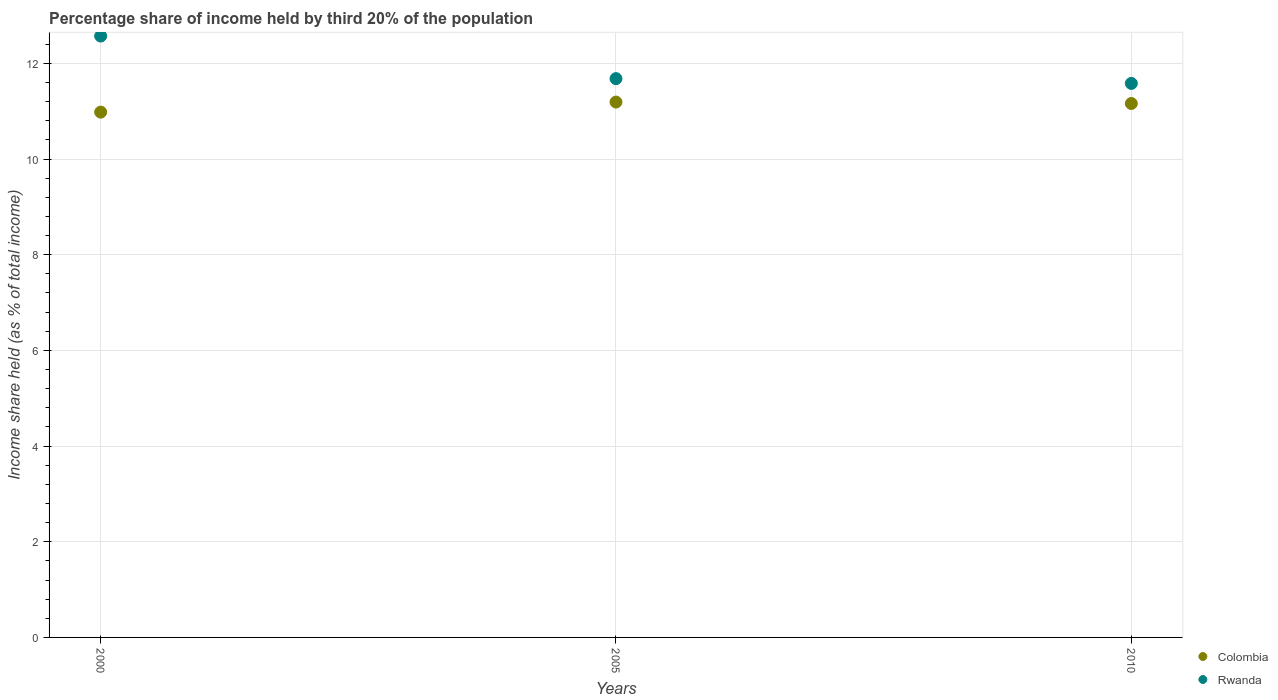How many different coloured dotlines are there?
Your answer should be compact. 2. What is the share of income held by third 20% of the population in Colombia in 2000?
Make the answer very short. 10.98. Across all years, what is the maximum share of income held by third 20% of the population in Colombia?
Offer a very short reply. 11.19. Across all years, what is the minimum share of income held by third 20% of the population in Colombia?
Keep it short and to the point. 10.98. In which year was the share of income held by third 20% of the population in Colombia minimum?
Your response must be concise. 2000. What is the total share of income held by third 20% of the population in Rwanda in the graph?
Ensure brevity in your answer.  35.83. What is the difference between the share of income held by third 20% of the population in Rwanda in 2000 and that in 2010?
Offer a terse response. 0.99. What is the difference between the share of income held by third 20% of the population in Colombia in 2005 and the share of income held by third 20% of the population in Rwanda in 2000?
Your answer should be compact. -1.38. What is the average share of income held by third 20% of the population in Colombia per year?
Your answer should be compact. 11.11. In the year 2000, what is the difference between the share of income held by third 20% of the population in Rwanda and share of income held by third 20% of the population in Colombia?
Provide a short and direct response. 1.59. What is the ratio of the share of income held by third 20% of the population in Rwanda in 2000 to that in 2005?
Provide a short and direct response. 1.08. What is the difference between the highest and the second highest share of income held by third 20% of the population in Colombia?
Keep it short and to the point. 0.03. What is the difference between the highest and the lowest share of income held by third 20% of the population in Rwanda?
Give a very brief answer. 0.99. In how many years, is the share of income held by third 20% of the population in Colombia greater than the average share of income held by third 20% of the population in Colombia taken over all years?
Your answer should be compact. 2. Does the share of income held by third 20% of the population in Rwanda monotonically increase over the years?
Ensure brevity in your answer.  No. Is the share of income held by third 20% of the population in Colombia strictly greater than the share of income held by third 20% of the population in Rwanda over the years?
Offer a terse response. No. Is the share of income held by third 20% of the population in Rwanda strictly less than the share of income held by third 20% of the population in Colombia over the years?
Provide a short and direct response. No. How many years are there in the graph?
Provide a short and direct response. 3. Does the graph contain grids?
Your answer should be compact. Yes. Where does the legend appear in the graph?
Ensure brevity in your answer.  Bottom right. How are the legend labels stacked?
Make the answer very short. Vertical. What is the title of the graph?
Your response must be concise. Percentage share of income held by third 20% of the population. What is the label or title of the X-axis?
Keep it short and to the point. Years. What is the label or title of the Y-axis?
Offer a terse response. Income share held (as % of total income). What is the Income share held (as % of total income) in Colombia in 2000?
Make the answer very short. 10.98. What is the Income share held (as % of total income) of Rwanda in 2000?
Ensure brevity in your answer.  12.57. What is the Income share held (as % of total income) of Colombia in 2005?
Offer a very short reply. 11.19. What is the Income share held (as % of total income) in Rwanda in 2005?
Provide a succinct answer. 11.68. What is the Income share held (as % of total income) of Colombia in 2010?
Give a very brief answer. 11.16. What is the Income share held (as % of total income) of Rwanda in 2010?
Provide a succinct answer. 11.58. Across all years, what is the maximum Income share held (as % of total income) in Colombia?
Your answer should be very brief. 11.19. Across all years, what is the maximum Income share held (as % of total income) in Rwanda?
Offer a terse response. 12.57. Across all years, what is the minimum Income share held (as % of total income) in Colombia?
Your response must be concise. 10.98. Across all years, what is the minimum Income share held (as % of total income) of Rwanda?
Make the answer very short. 11.58. What is the total Income share held (as % of total income) of Colombia in the graph?
Your answer should be very brief. 33.33. What is the total Income share held (as % of total income) of Rwanda in the graph?
Your answer should be very brief. 35.83. What is the difference between the Income share held (as % of total income) of Colombia in 2000 and that in 2005?
Your answer should be very brief. -0.21. What is the difference between the Income share held (as % of total income) in Rwanda in 2000 and that in 2005?
Your answer should be compact. 0.89. What is the difference between the Income share held (as % of total income) of Colombia in 2000 and that in 2010?
Ensure brevity in your answer.  -0.18. What is the difference between the Income share held (as % of total income) in Rwanda in 2000 and that in 2010?
Keep it short and to the point. 0.99. What is the difference between the Income share held (as % of total income) of Colombia in 2005 and that in 2010?
Your response must be concise. 0.03. What is the difference between the Income share held (as % of total income) of Colombia in 2000 and the Income share held (as % of total income) of Rwanda in 2010?
Provide a short and direct response. -0.6. What is the difference between the Income share held (as % of total income) in Colombia in 2005 and the Income share held (as % of total income) in Rwanda in 2010?
Provide a succinct answer. -0.39. What is the average Income share held (as % of total income) in Colombia per year?
Keep it short and to the point. 11.11. What is the average Income share held (as % of total income) of Rwanda per year?
Give a very brief answer. 11.94. In the year 2000, what is the difference between the Income share held (as % of total income) of Colombia and Income share held (as % of total income) of Rwanda?
Offer a terse response. -1.59. In the year 2005, what is the difference between the Income share held (as % of total income) of Colombia and Income share held (as % of total income) of Rwanda?
Give a very brief answer. -0.49. In the year 2010, what is the difference between the Income share held (as % of total income) of Colombia and Income share held (as % of total income) of Rwanda?
Ensure brevity in your answer.  -0.42. What is the ratio of the Income share held (as % of total income) in Colombia in 2000 to that in 2005?
Give a very brief answer. 0.98. What is the ratio of the Income share held (as % of total income) in Rwanda in 2000 to that in 2005?
Make the answer very short. 1.08. What is the ratio of the Income share held (as % of total income) in Colombia in 2000 to that in 2010?
Offer a very short reply. 0.98. What is the ratio of the Income share held (as % of total income) of Rwanda in 2000 to that in 2010?
Ensure brevity in your answer.  1.09. What is the ratio of the Income share held (as % of total income) of Rwanda in 2005 to that in 2010?
Your response must be concise. 1.01. What is the difference between the highest and the second highest Income share held (as % of total income) in Colombia?
Provide a short and direct response. 0.03. What is the difference between the highest and the second highest Income share held (as % of total income) of Rwanda?
Keep it short and to the point. 0.89. What is the difference between the highest and the lowest Income share held (as % of total income) in Colombia?
Make the answer very short. 0.21. 